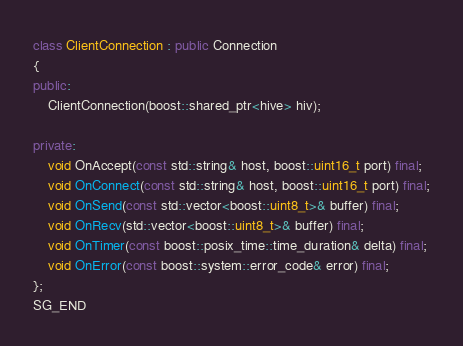Convert code to text. <code><loc_0><loc_0><loc_500><loc_500><_C++_>class ClientConnection : public Connection
{
public:
	ClientConnection(boost::shared_ptr<hive> hiv);

private:
	void OnAccept(const std::string& host, boost::uint16_t port) final;
	void OnConnect(const std::string& host, boost::uint16_t port) final;
	void OnSend(const std::vector<boost::uint8_t>& buffer) final;
	void OnRecv(std::vector<boost::uint8_t>& buffer) final;
	void OnTimer(const boost::posix_time::time_duration& delta) final;
	void OnError(const boost::system::error_code& error) final;
};
SG_END</code> 